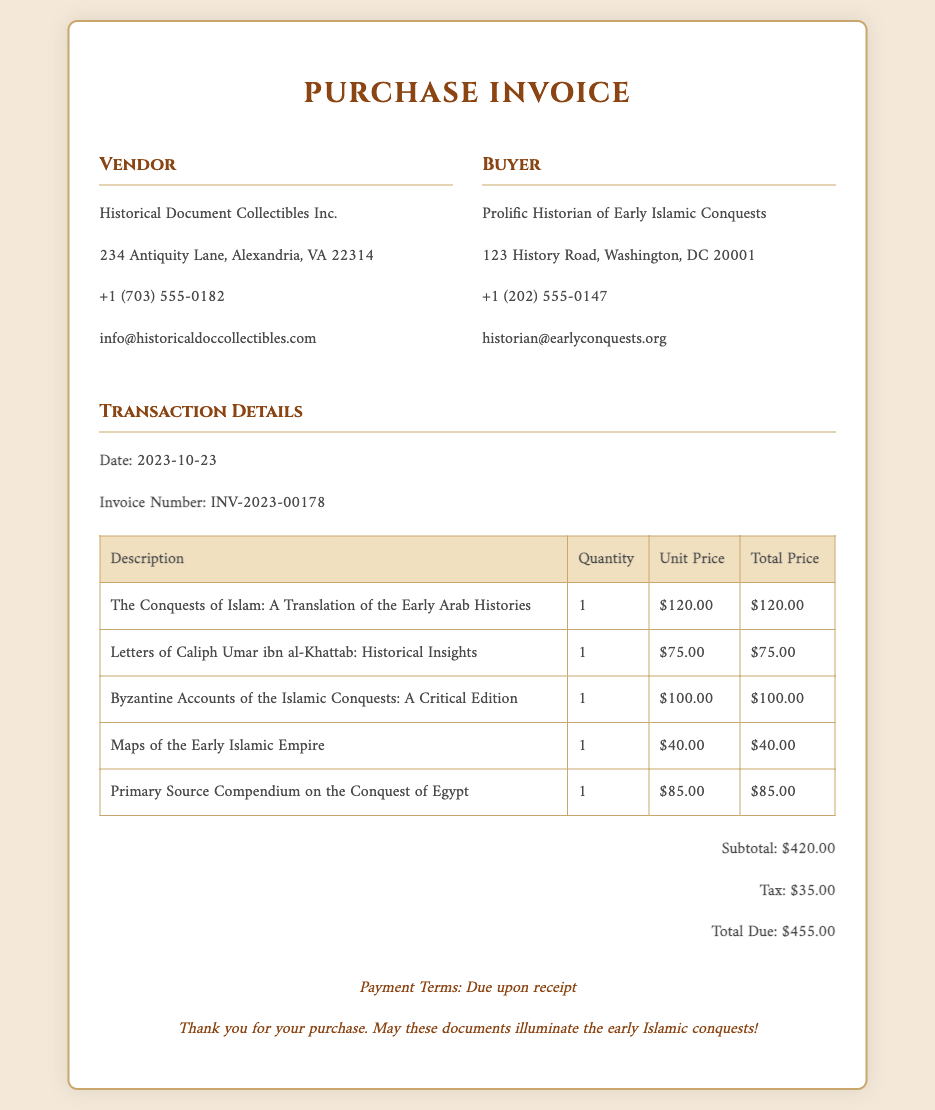What is the vendor name? The vendor name is listed in the document as "Historical Document Collectibles Inc."
Answer: Historical Document Collectibles Inc What is the total amount due? The total amount due is specified in the document after calculating subtotal and tax, which is $455.00.
Answer: $455.00 What is the date of the transaction? The date is mentioned in the document and indicates when the transaction took place, which is 2023-10-23.
Answer: 2023-10-23 How many primary source documents were purchased? The document lists five individual items corresponding to primary source documents that were purchased.
Answer: 5 What is the invoice number? The invoice number is a unique identifier for the transaction and is given as INV-2023-00178.
Answer: INV-2023-00178 What is the unit price of "Maps of the Early Islamic Empire"? The document specifies the unit price for "Maps of the Early Islamic Empire," which is $40.00.
Answer: $40.00 Who is the buyer? The buyer is identified in the document as "Prolific Historian of Early Islamic Conquests."
Answer: Prolific Historian of Early Islamic Conquests What payment terms are specified? The payment terms detail how and when payment is expected, which is "Due upon receipt."
Answer: Due upon receipt What is the subtotal of the purchases? The subtotal is the sum of the individual item prices before tax, which is recorded as $420.00.
Answer: $420.00 